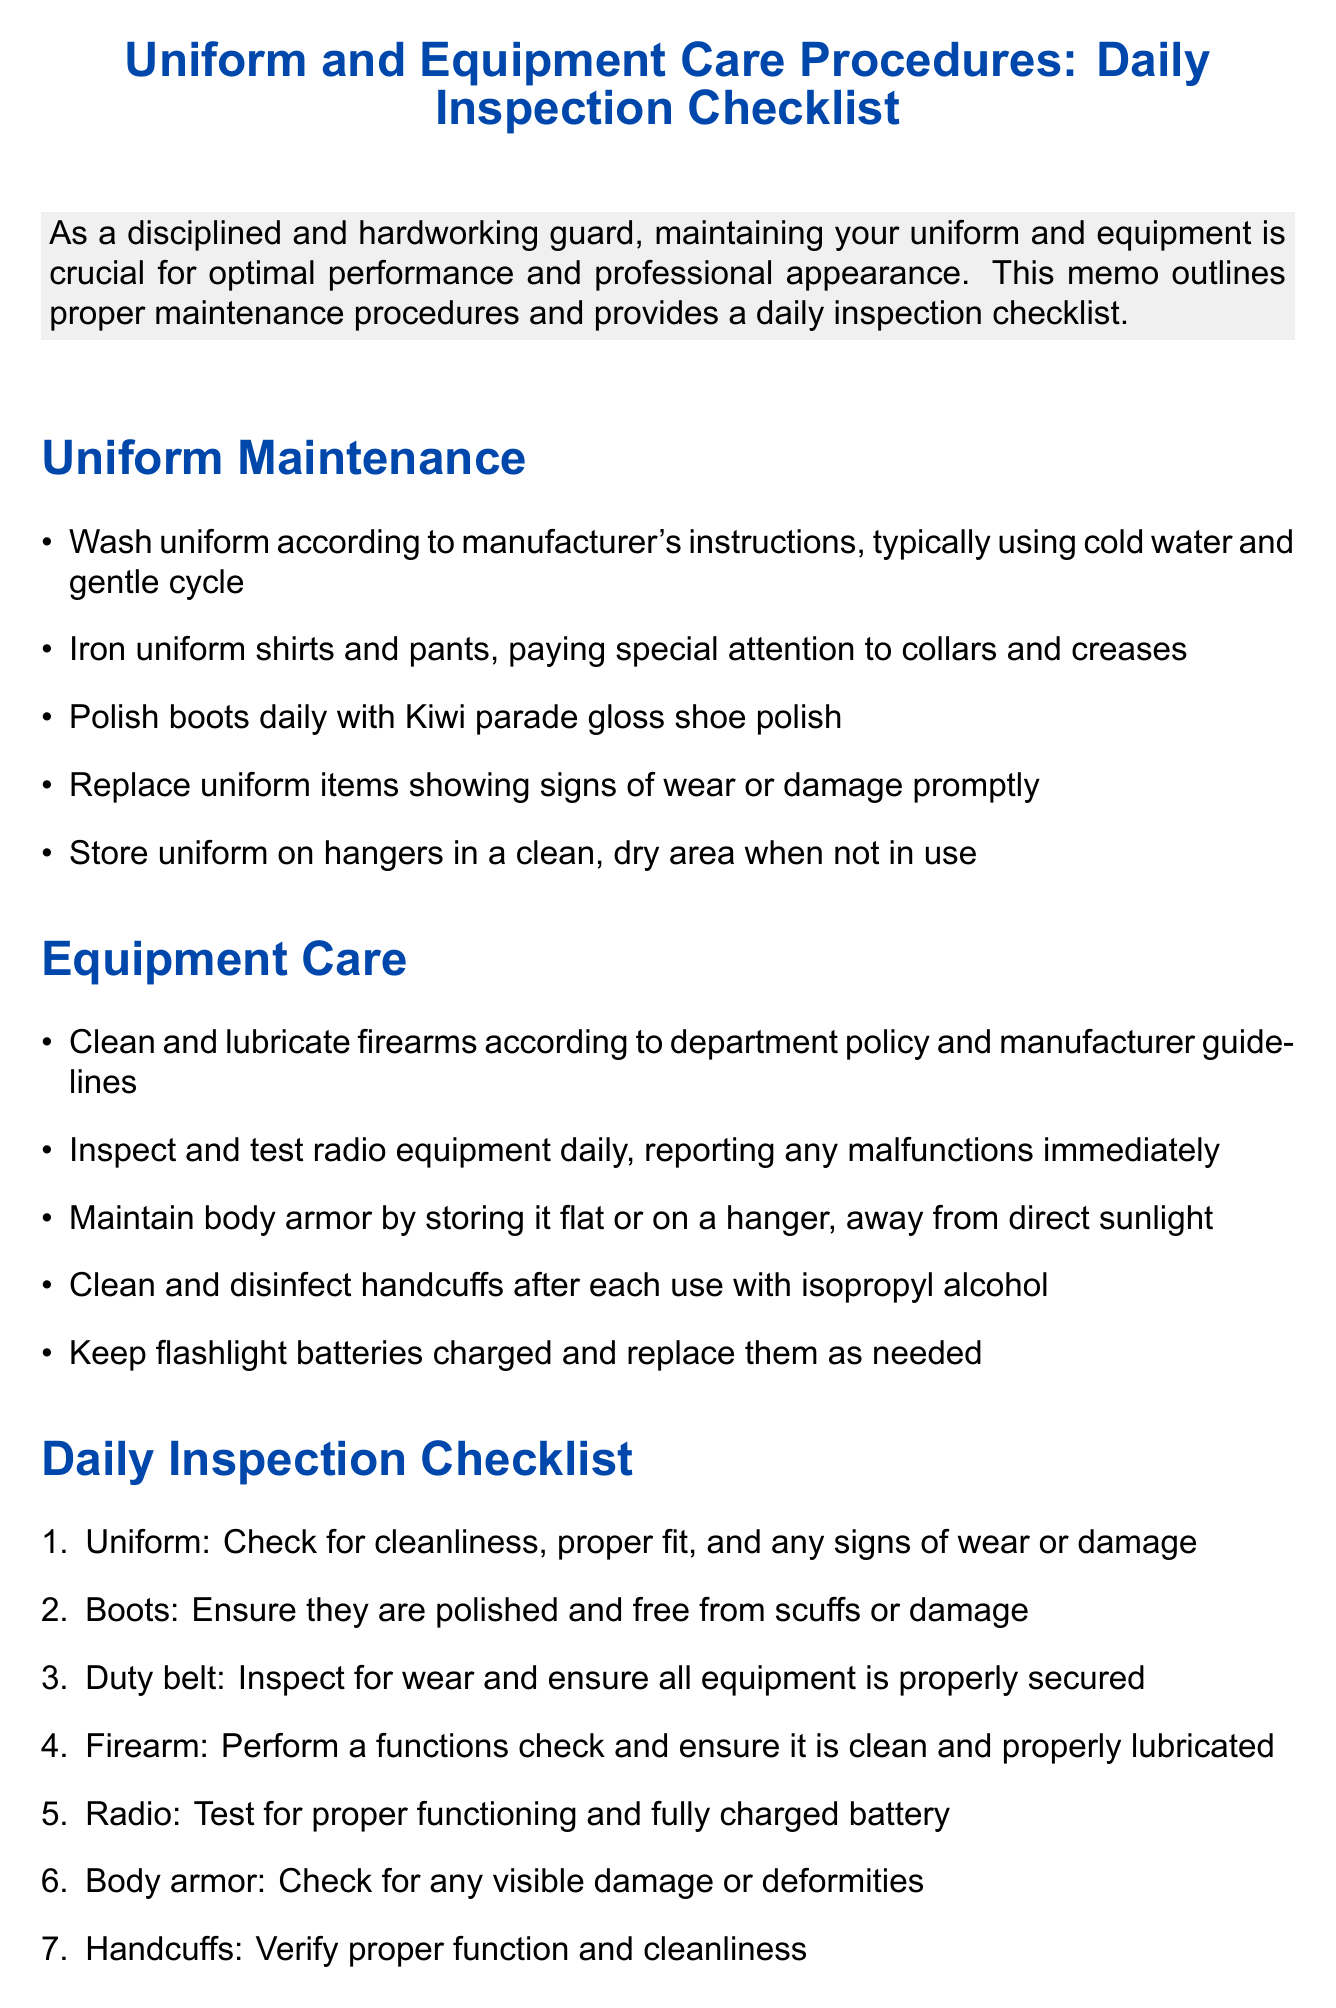What is the title of the memo? The title of the memo is prominently displayed at the top of the document, which outlines the subject matter.
Answer: Uniform and Equipment Care Procedures: Daily Inspection Checklist How should the uniform be washed? The memo specifies the washing instructions for the uniform, mentioning what conditions to use during the wash.
Answer: Cold water and gentle cycle What is the first item in the daily inspection checklist? The daily inspection checklist is structured in an enumerated list, and the first item is directly stated.
Answer: Uniform: Check for cleanliness, proper fit, and any signs of wear or damage What is advised for maintaining boots? The memo provides specific maintenance tips for boots, reflecting their importance in uniform care.
Answer: Polish boots daily with Kiwi parade gloss shoe polish How frequently should the flashlight batteries be checked? The memo advises on the care of the flashlight, indicating the necessity of battery maintenance.
Answer: As needed What must be done with handcuffs after each use? The memo details cleaning procedures for handcuffs, ensuring proper hygiene and functionality.
Answer: Clean and disinfect handcuffs after each use with isopropyl alcohol Why is equipment care emphasized in this memo? The introduction highlights the significance of maintaining uniform and equipment for performance and professionalism.
Answer: For optimal performance and professional appearance What should be done if the body armor is damaged? The memo discusses the storage and maintenance of body armor, implying required actions for damage.
Answer: Check for any visible damage or deformities Who is the target audience of this memo? The introduction sets the context for the memo, identifying the primary audience.
Answer: Guards 